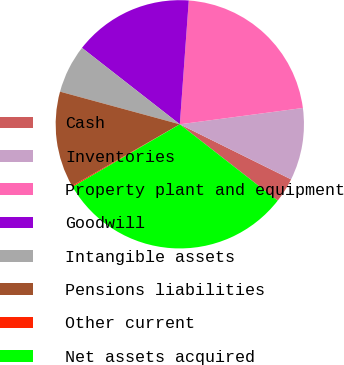Convert chart. <chart><loc_0><loc_0><loc_500><loc_500><pie_chart><fcel>Cash<fcel>Inventories<fcel>Property plant and equipment<fcel>Goodwill<fcel>Intangible assets<fcel>Pensions liabilities<fcel>Other current<fcel>Net assets acquired<nl><fcel>3.23%<fcel>9.41%<fcel>21.75%<fcel>15.59%<fcel>6.32%<fcel>12.5%<fcel>0.14%<fcel>31.04%<nl></chart> 